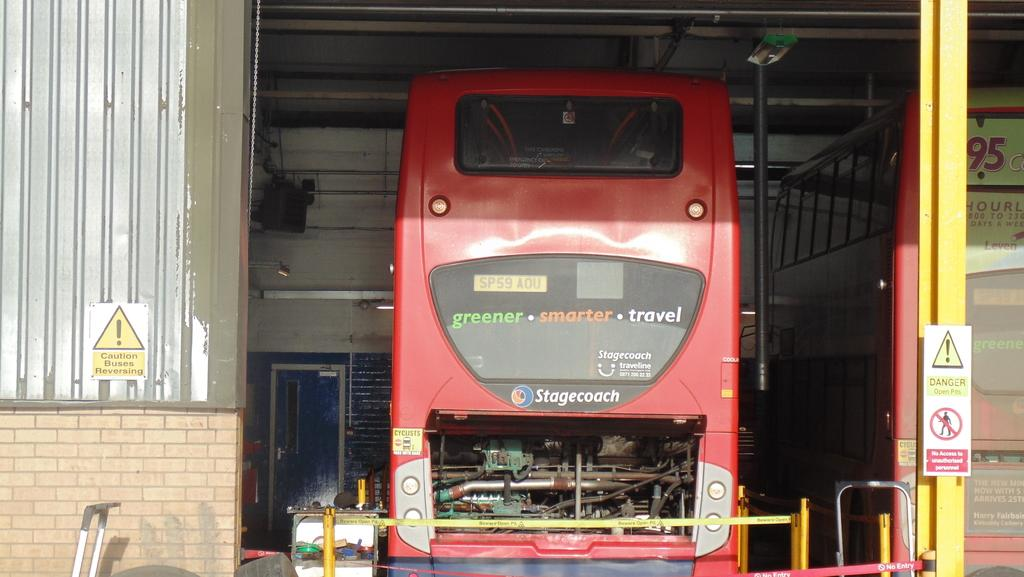What type of vehicle is in the image? The specific type of vehicle is not mentioned, but there is a vehicle present in the image. What else can be seen in the image besides the vehicle? There is a pole, a door, boards, and a wall in the image. Can you describe the pole in the image? The pole is a vertical structure that can be seen in the image. What might the boards be used for in the image? The boards could be used for various purposes, such as construction or signage, but their specific use is not mentioned. What teaching method is being used by the vehicle in the image? There is no teaching method or any indication of teaching in the image; it features a vehicle and other objects. 